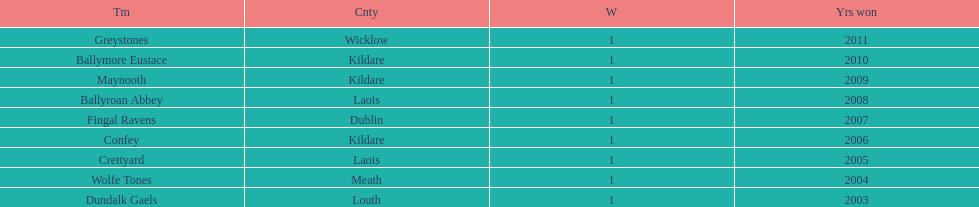Which county had the most number of wins? Kildare. 